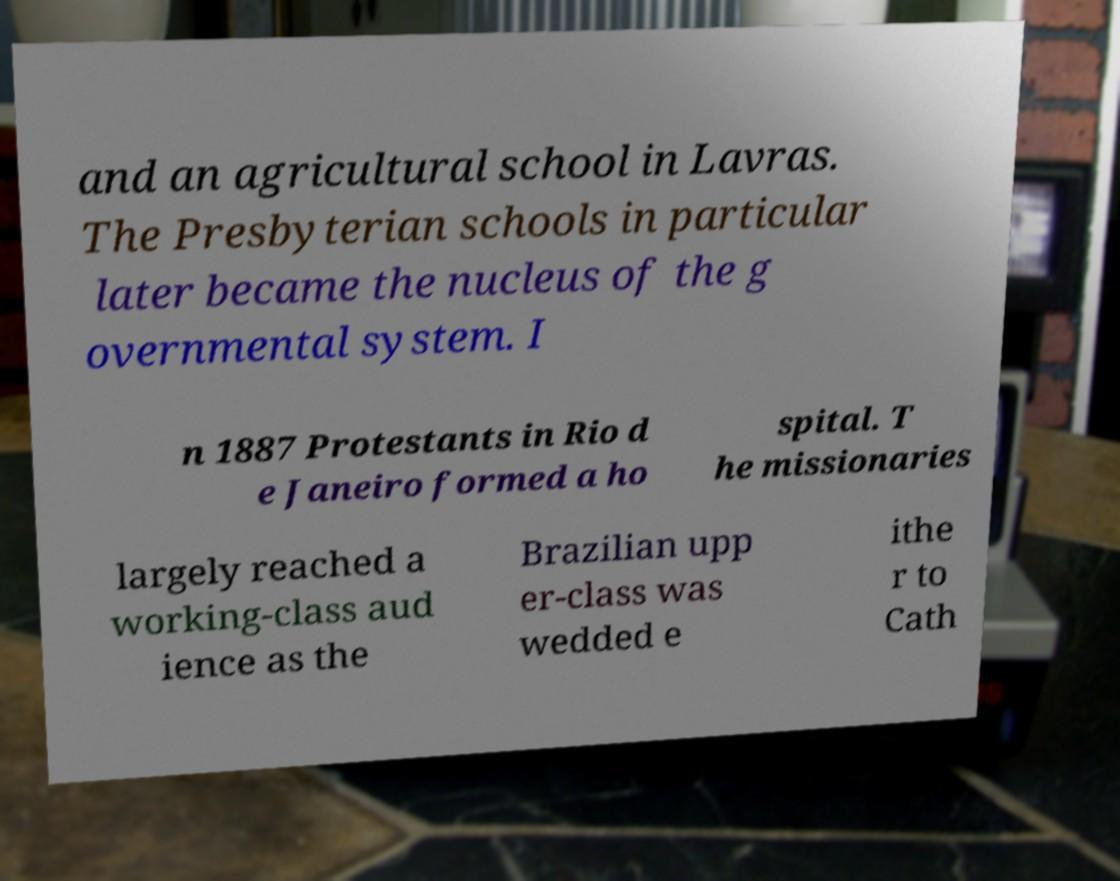Please identify and transcribe the text found in this image. and an agricultural school in Lavras. The Presbyterian schools in particular later became the nucleus of the g overnmental system. I n 1887 Protestants in Rio d e Janeiro formed a ho spital. T he missionaries largely reached a working-class aud ience as the Brazilian upp er-class was wedded e ithe r to Cath 